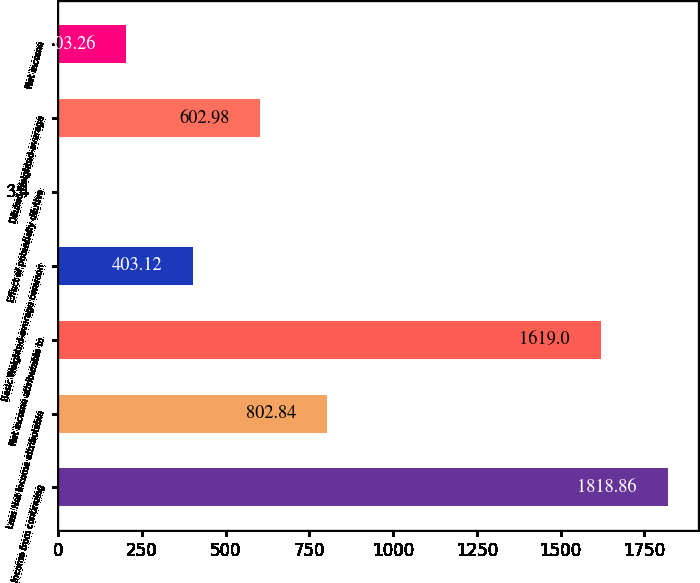Convert chart. <chart><loc_0><loc_0><loc_500><loc_500><bar_chart><fcel>Income from continuing<fcel>Less Net income attributable<fcel>Net income attributable to<fcel>Basic Weighted-average common<fcel>Effect of potentially dilutive<fcel>Diluted Weighted-average<fcel>Net income<nl><fcel>1818.86<fcel>802.84<fcel>1619<fcel>403.12<fcel>3.4<fcel>602.98<fcel>203.26<nl></chart> 